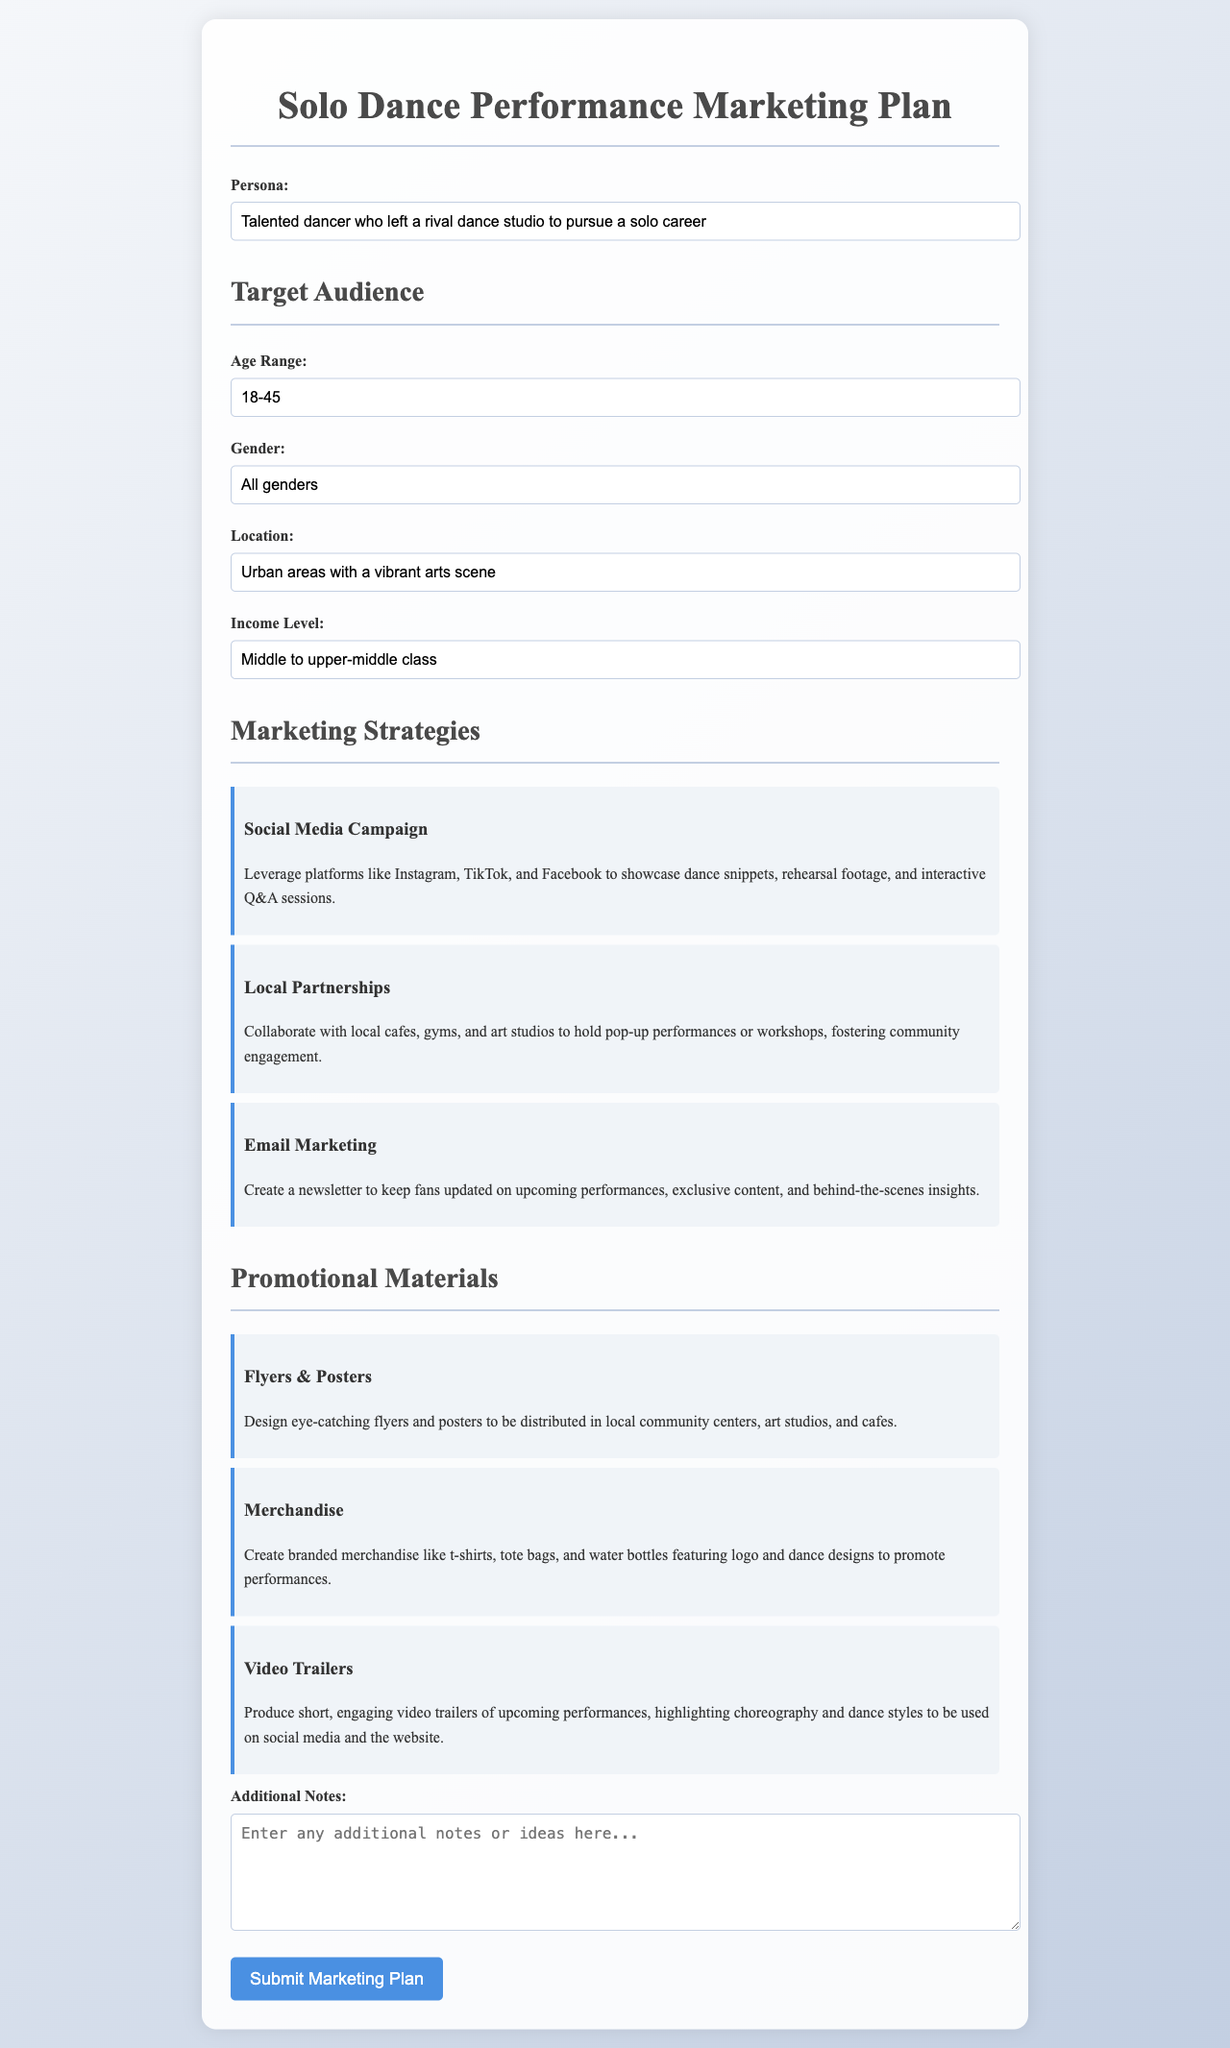What is the target audience's age range? The age range specified for the target audience is noted in the document.
Answer: 18-45 What is the gender of the target audience? The document specifies the gender category of the target audience, which is inclusive.
Answer: All genders What location is identified for the target audience? The document describes the geographic area where the audience is expected to be located.
Answer: Urban areas with a vibrant arts scene What is the income level of the target audience? Information about the income level of the target audience is provided in the document.
Answer: Middle to upper-middle class Name one marketing strategy mentioned in the document. The document lists various strategies for marketing the solo dance performance.
Answer: Social Media Campaign How many promotional materials are mentioned in the document? The document enumerates the types of promotional materials available.
Answer: Three What type of merchandise is suggested in the marketing plan? The document outlines options for promotional items to create and sell.
Answer: Branded merchandise What is the purpose of the email marketing strategy? The document describes the aim of maintaining communication with potential audience members.
Answer: To keep fans updated What is the first item in the Marketing Strategies section? The order of items in the document can be referenced for specific content details.
Answer: Social Media Campaign 